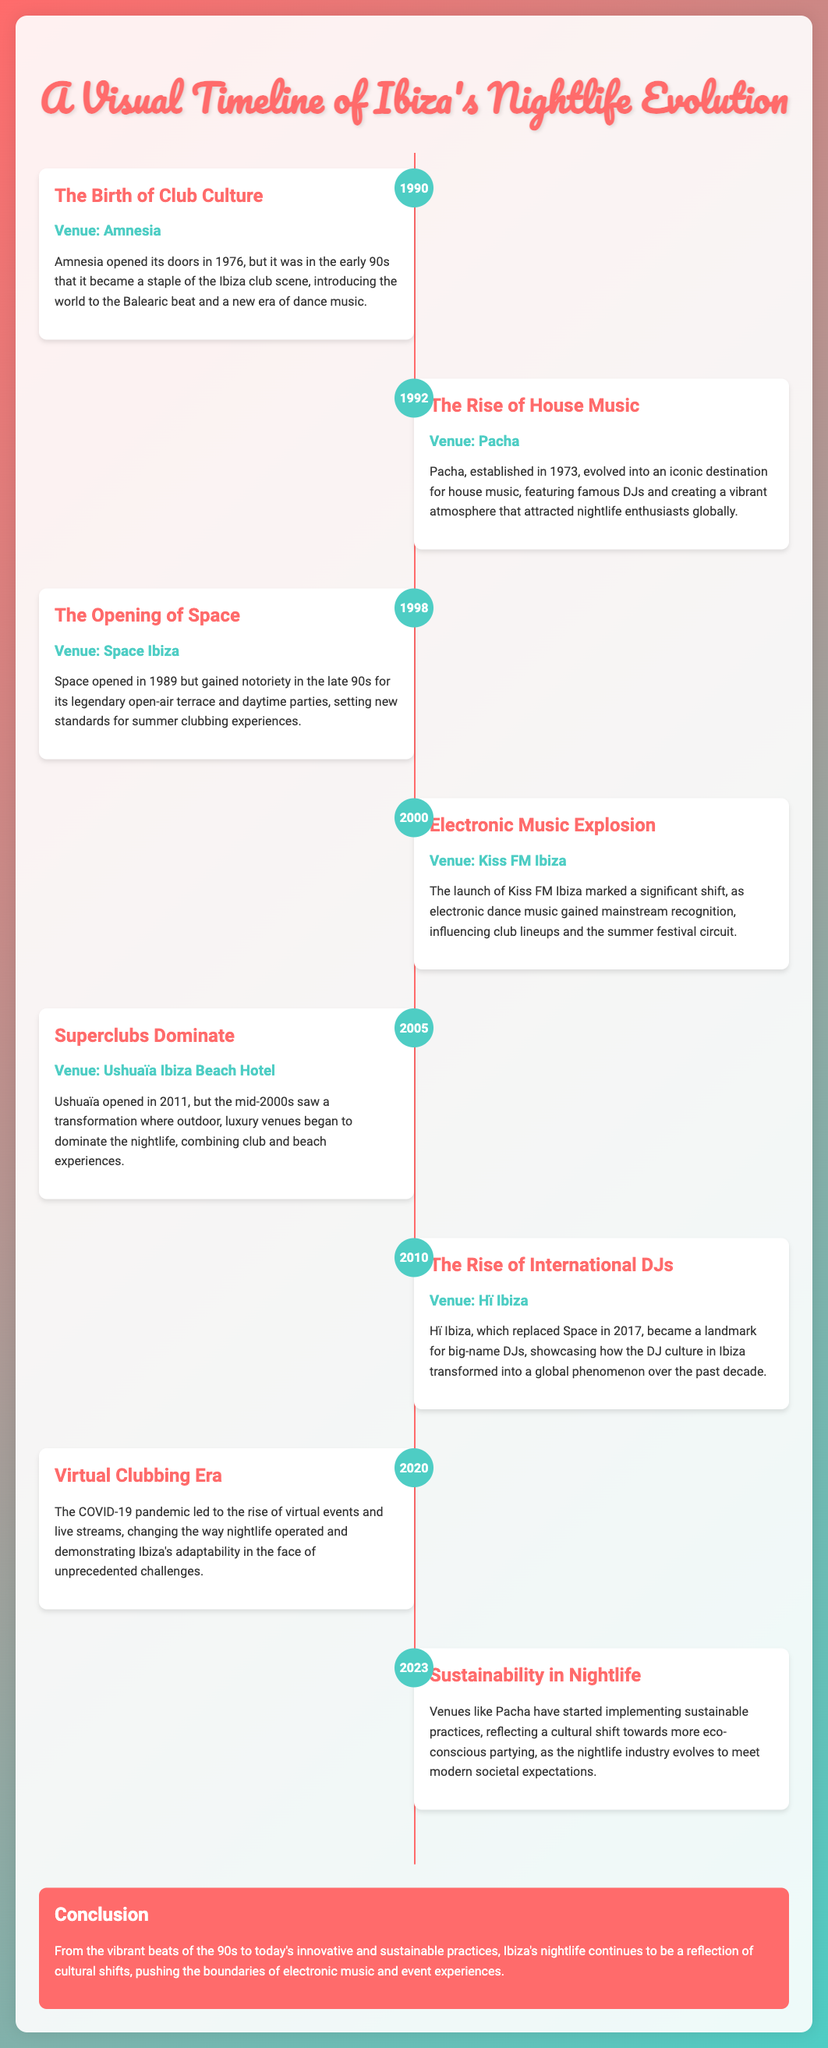What year did Amnesia become a staple of the Ibiza club scene? The document states that Amnesia became a staple of the Ibiza club scene in the early 90s.
Answer: 1990 Which venue is associated with the rise of house music? The timeline notes that Pacha evolved into an iconic destination for house music.
Answer: Pacha What significant event in nightlife occurred in 2020? The document mentions that the COVID-19 pandemic led to the rise of virtual events and live streams.
Answer: Virtual Clubbing Era Which venue opened its doors in 1998? According to the timeline, Space Ibiza is mentioned as opening in late 90s.
Answer: Space Ibiza What trend was noted in the nightlife practices in 2023? The document indicates that venues like Pacha have started implementing sustainable practices.
Answer: Sustainability In what year did Hï Ibiza become a landmark for big-name DJs? The document states that Hï Ibiza replaced Space in 2017 and became a notable venue since then.
Answer: 2010 What does the conclusion of the document highlight about Ibiza's nightlife? The conclusion discusses cultural shifts and pushing boundaries of electronic music and event experiences.
Answer: Cultural shifts What was a key transformation in the mid-2000s regarding nightlife venues? The timeline describes a transformation where outdoor, luxury venues began to dominate the nightlife.
Answer: Outdoor luxury venues 